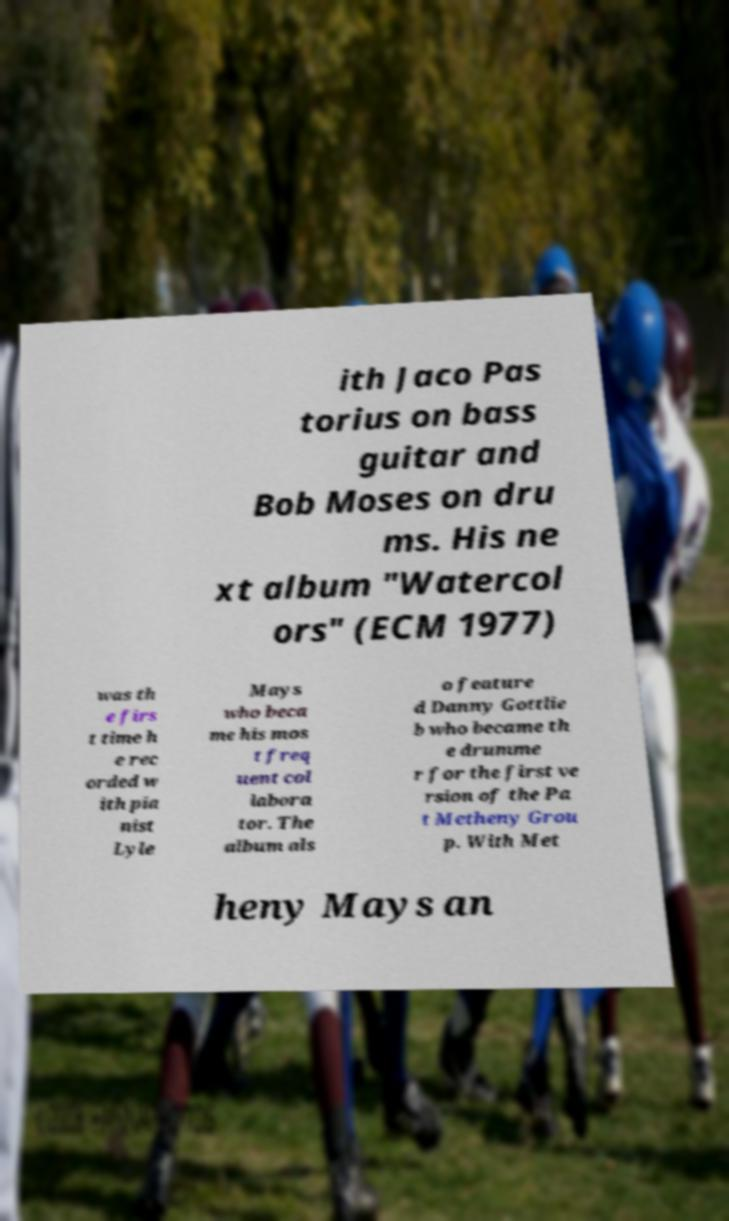Can you accurately transcribe the text from the provided image for me? ith Jaco Pas torius on bass guitar and Bob Moses on dru ms. His ne xt album "Watercol ors" (ECM 1977) was th e firs t time h e rec orded w ith pia nist Lyle Mays who beca me his mos t freq uent col labora tor. The album als o feature d Danny Gottlie b who became th e drumme r for the first ve rsion of the Pa t Metheny Grou p. With Met heny Mays an 